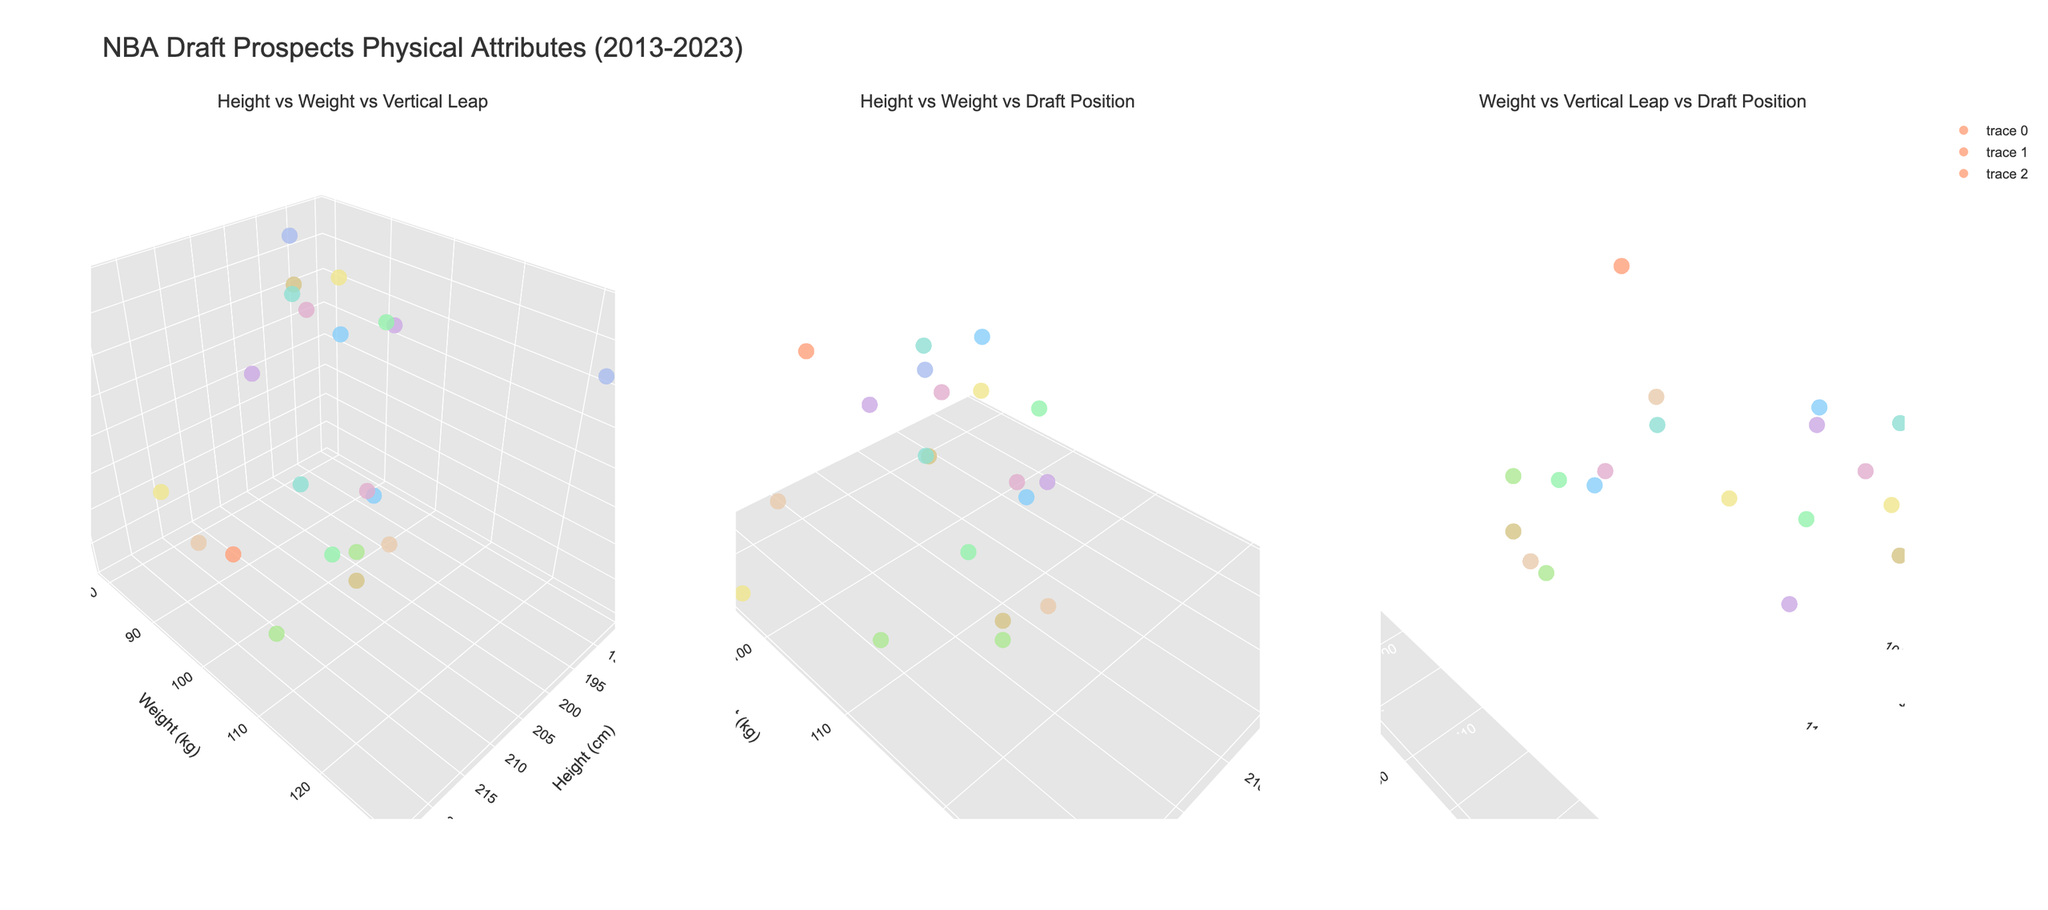what are the three axes in the first subplot? The three axes in the first subplot are "Height (cm)", "Weight (kg)", and "Vertical Leap (cm)" as indicated by their titles.
Answer: Height, Weight, Vertical Leap what's the title of the whole figure? The title of the entire figure is given at the top of the plot and reads "NBA Draft Prospects Physical Attributes (2013-2023)".
Answer: NBA Draft Prospects Physical Attributes (2013-2023) who has the highest vertical leap, and what is his value? The highest vertical leap value can be identified by finding the top-most point along the vertical axis in the first subplot or the third subplot. Andrew Wiggins and Ja Morant both have the highest vertical leap of 112 cm.
Answer: Andrew Wiggins and Jer Morant, 112 cm Which player is the heaviest, and how heavy is he? To find the heaviest player, look for the farthest point along the weight axis in the subplots. Zion Williamson is the heaviest player with a weight of 129 kg.
Answer: Zion Williamson, 129 kg What is the draft position for the tallest player? To find the draft position for the tallest player, locate the point with the maximum height and hover over it in the second subplot. Victor Wembanyama is the tallest at 224 cm, and his draft position is 1.
Answer: 1 What is the relationship between height and draft position based on the figure? In the second subplot, observe the trend between height and draft position. Taller players don't necessarily have better draft positions, as indicated by the scattered points with draft positions both high and low for various heights.
Answer: No clear relationship Does a higher vertical leap correlate with a better draft position? In the third subplot, analyze the spread of points along the vertical leap and draft position axes. You may notice a trend where players with higher vertical leaps tend to have better draft positions, but there are exceptions.
Answer: General correlation, but not absolute Which draft year's players are predominantly represented in the figure? By observing the color coding of the data points, you can identify which draft years are predominantly represented. The color scale indicates multiple years, but more recent years like 2023, 2022, and 2021 appear frequently.
Answer: 2021, 2022, 2023 How does weight vary among the top 3 draft picks? Focusing on the top 3 draft picks in the second and third subplots, note their weights. There's a variation from lighter players like De'Aaron Fox (79 kg) to heavier ones like Zion Williamson (129 kg).
Answer: Significant variation Who has the highest draft position among players with a vertical leap above 100 cm? To answer this, look at points above 100 cm on the vertical leap axis across the subplots. Anthony Edwards, with a vertical leap of 109 cm and a draft position of 1, has the highest draft position among these players.
Answer: Anthony Edwards, 1 